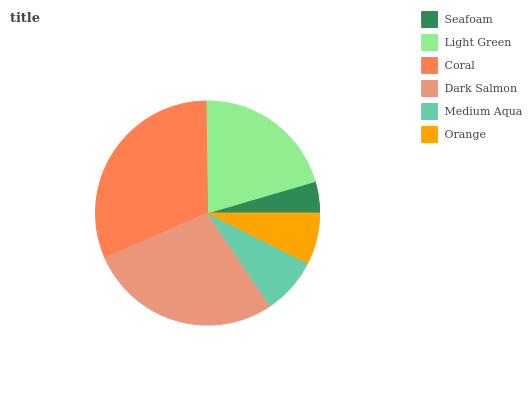Is Seafoam the minimum?
Answer yes or no. Yes. Is Coral the maximum?
Answer yes or no. Yes. Is Light Green the minimum?
Answer yes or no. No. Is Light Green the maximum?
Answer yes or no. No. Is Light Green greater than Seafoam?
Answer yes or no. Yes. Is Seafoam less than Light Green?
Answer yes or no. Yes. Is Seafoam greater than Light Green?
Answer yes or no. No. Is Light Green less than Seafoam?
Answer yes or no. No. Is Light Green the high median?
Answer yes or no. Yes. Is Medium Aqua the low median?
Answer yes or no. Yes. Is Medium Aqua the high median?
Answer yes or no. No. Is Seafoam the low median?
Answer yes or no. No. 